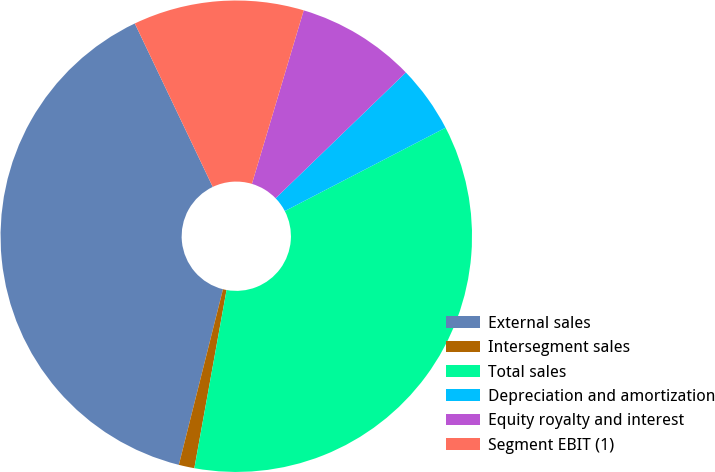Convert chart. <chart><loc_0><loc_0><loc_500><loc_500><pie_chart><fcel>External sales<fcel>Intersegment sales<fcel>Total sales<fcel>Depreciation and amortization<fcel>Equity royalty and interest<fcel>Segment EBIT (1)<nl><fcel>39.0%<fcel>1.07%<fcel>35.46%<fcel>4.61%<fcel>8.16%<fcel>11.7%<nl></chart> 